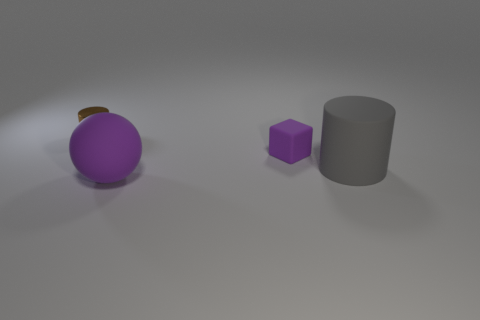Subtract all spheres. How many objects are left? 3 Add 1 matte cylinders. How many matte cylinders are left? 2 Add 2 gray objects. How many gray objects exist? 3 Add 3 blue objects. How many objects exist? 7 Subtract 0 yellow spheres. How many objects are left? 4 Subtract 1 cylinders. How many cylinders are left? 1 Subtract all brown balls. Subtract all yellow cylinders. How many balls are left? 1 Subtract all cyan cylinders. How many blue balls are left? 0 Subtract all tiny yellow matte balls. Subtract all brown objects. How many objects are left? 3 